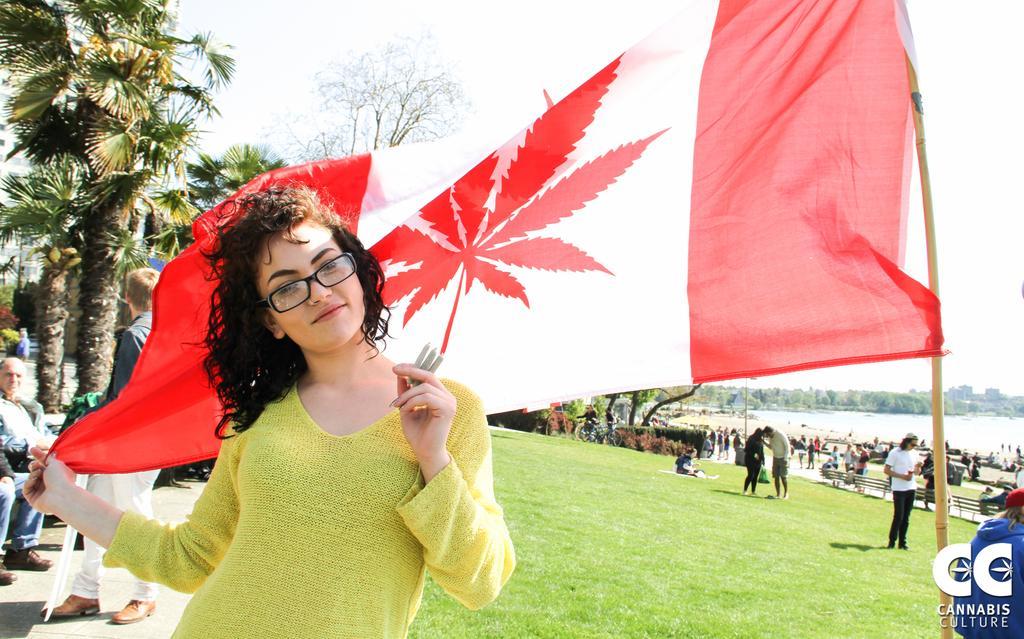Describe this image in one or two sentences. In this picture there is a woman wearing yellow dress is standing and holding a flag behind her and there are few other persons trees and greenery ground behind her and there is water and trees in the background. 